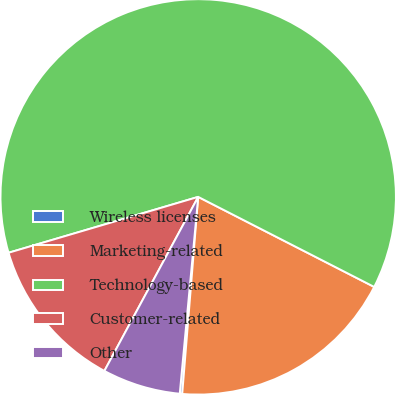Convert chart. <chart><loc_0><loc_0><loc_500><loc_500><pie_chart><fcel>Wireless licenses<fcel>Marketing-related<fcel>Technology-based<fcel>Customer-related<fcel>Other<nl><fcel>0.2%<fcel>18.76%<fcel>62.08%<fcel>12.57%<fcel>6.38%<nl></chart> 